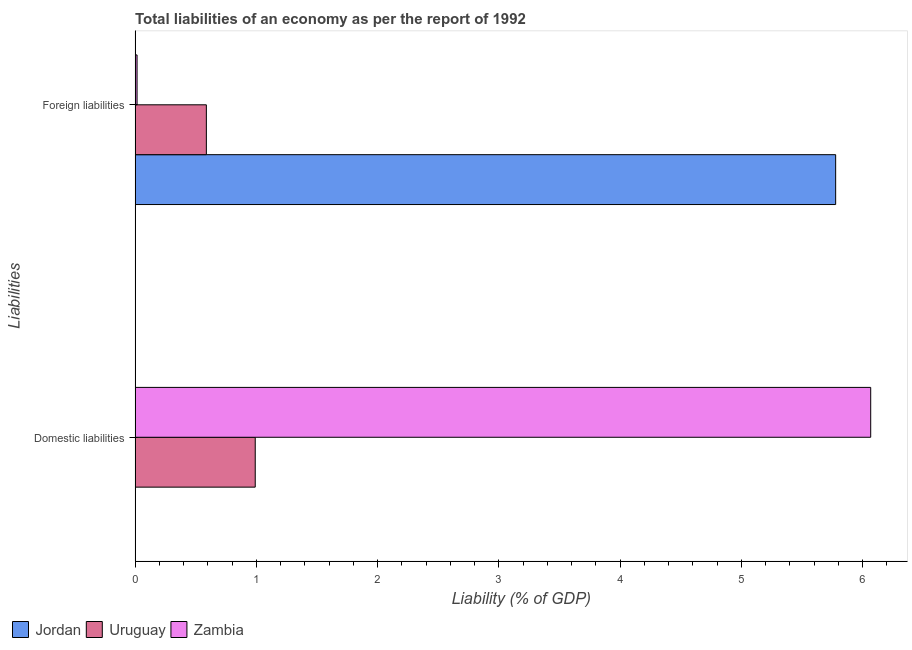How many different coloured bars are there?
Give a very brief answer. 3. Are the number of bars on each tick of the Y-axis equal?
Keep it short and to the point. No. How many bars are there on the 2nd tick from the bottom?
Provide a short and direct response. 3. What is the label of the 2nd group of bars from the top?
Keep it short and to the point. Domestic liabilities. What is the incurrence of foreign liabilities in Jordan?
Keep it short and to the point. 5.78. Across all countries, what is the maximum incurrence of domestic liabilities?
Offer a very short reply. 6.07. Across all countries, what is the minimum incurrence of domestic liabilities?
Keep it short and to the point. 0. In which country was the incurrence of foreign liabilities maximum?
Provide a short and direct response. Jordan. What is the total incurrence of domestic liabilities in the graph?
Your answer should be compact. 7.06. What is the difference between the incurrence of foreign liabilities in Zambia and that in Uruguay?
Offer a very short reply. -0.57. What is the difference between the incurrence of domestic liabilities in Zambia and the incurrence of foreign liabilities in Jordan?
Provide a short and direct response. 0.29. What is the average incurrence of foreign liabilities per country?
Make the answer very short. 2.13. What is the difference between the incurrence of foreign liabilities and incurrence of domestic liabilities in Zambia?
Ensure brevity in your answer.  -6.05. In how many countries, is the incurrence of foreign liabilities greater than 2.8 %?
Your response must be concise. 1. What is the ratio of the incurrence of foreign liabilities in Jordan to that in Zambia?
Make the answer very short. 350.43. Are the values on the major ticks of X-axis written in scientific E-notation?
Keep it short and to the point. No. Does the graph contain any zero values?
Your response must be concise. Yes. Where does the legend appear in the graph?
Offer a very short reply. Bottom left. What is the title of the graph?
Offer a terse response. Total liabilities of an economy as per the report of 1992. What is the label or title of the X-axis?
Your response must be concise. Liability (% of GDP). What is the label or title of the Y-axis?
Your response must be concise. Liabilities. What is the Liability (% of GDP) in Jordan in Domestic liabilities?
Your answer should be very brief. 0. What is the Liability (% of GDP) in Uruguay in Domestic liabilities?
Your response must be concise. 0.99. What is the Liability (% of GDP) of Zambia in Domestic liabilities?
Your response must be concise. 6.07. What is the Liability (% of GDP) of Jordan in Foreign liabilities?
Give a very brief answer. 5.78. What is the Liability (% of GDP) in Uruguay in Foreign liabilities?
Keep it short and to the point. 0.59. What is the Liability (% of GDP) of Zambia in Foreign liabilities?
Make the answer very short. 0.02. Across all Liabilities, what is the maximum Liability (% of GDP) of Jordan?
Keep it short and to the point. 5.78. Across all Liabilities, what is the maximum Liability (% of GDP) in Uruguay?
Offer a terse response. 0.99. Across all Liabilities, what is the maximum Liability (% of GDP) of Zambia?
Make the answer very short. 6.07. Across all Liabilities, what is the minimum Liability (% of GDP) of Jordan?
Ensure brevity in your answer.  0. Across all Liabilities, what is the minimum Liability (% of GDP) of Uruguay?
Your response must be concise. 0.59. Across all Liabilities, what is the minimum Liability (% of GDP) in Zambia?
Your answer should be very brief. 0.02. What is the total Liability (% of GDP) in Jordan in the graph?
Give a very brief answer. 5.78. What is the total Liability (% of GDP) in Uruguay in the graph?
Make the answer very short. 1.58. What is the total Liability (% of GDP) of Zambia in the graph?
Offer a very short reply. 6.08. What is the difference between the Liability (% of GDP) in Uruguay in Domestic liabilities and that in Foreign liabilities?
Your response must be concise. 0.4. What is the difference between the Liability (% of GDP) of Zambia in Domestic liabilities and that in Foreign liabilities?
Your answer should be very brief. 6.05. What is the difference between the Liability (% of GDP) in Uruguay in Domestic liabilities and the Liability (% of GDP) in Zambia in Foreign liabilities?
Make the answer very short. 0.97. What is the average Liability (% of GDP) of Jordan per Liabilities?
Keep it short and to the point. 2.89. What is the average Liability (% of GDP) in Uruguay per Liabilities?
Ensure brevity in your answer.  0.79. What is the average Liability (% of GDP) in Zambia per Liabilities?
Keep it short and to the point. 3.04. What is the difference between the Liability (% of GDP) of Uruguay and Liability (% of GDP) of Zambia in Domestic liabilities?
Keep it short and to the point. -5.08. What is the difference between the Liability (% of GDP) of Jordan and Liability (% of GDP) of Uruguay in Foreign liabilities?
Your response must be concise. 5.19. What is the difference between the Liability (% of GDP) of Jordan and Liability (% of GDP) of Zambia in Foreign liabilities?
Your response must be concise. 5.76. What is the difference between the Liability (% of GDP) in Uruguay and Liability (% of GDP) in Zambia in Foreign liabilities?
Your answer should be very brief. 0.57. What is the ratio of the Liability (% of GDP) in Uruguay in Domestic liabilities to that in Foreign liabilities?
Your response must be concise. 1.69. What is the ratio of the Liability (% of GDP) of Zambia in Domestic liabilities to that in Foreign liabilities?
Your answer should be compact. 367.97. What is the difference between the highest and the second highest Liability (% of GDP) in Uruguay?
Provide a succinct answer. 0.4. What is the difference between the highest and the second highest Liability (% of GDP) in Zambia?
Give a very brief answer. 6.05. What is the difference between the highest and the lowest Liability (% of GDP) of Jordan?
Make the answer very short. 5.78. What is the difference between the highest and the lowest Liability (% of GDP) of Uruguay?
Provide a succinct answer. 0.4. What is the difference between the highest and the lowest Liability (% of GDP) of Zambia?
Your answer should be very brief. 6.05. 